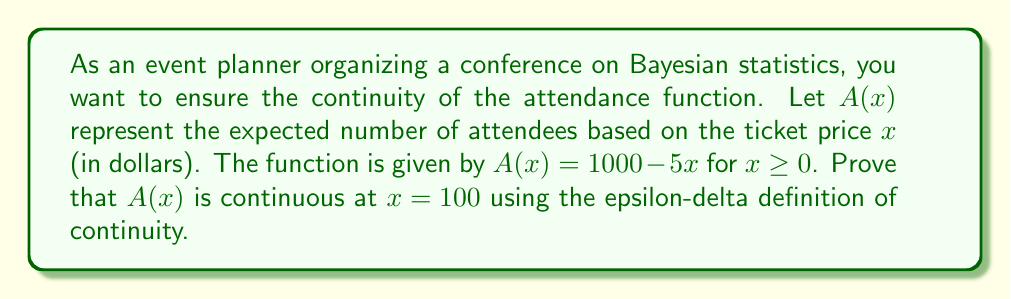Solve this math problem. To prove the continuity of $A(x)$ at $x = 100$ using the epsilon-delta definition, we need to show that for any given $\epsilon > 0$, there exists a $\delta > 0$ such that:

$$|A(x) - A(100)| < \epsilon \text{ whenever } |x - 100| < \delta$$

Let's approach this step-by-step:

1) First, let's calculate $A(100)$:
   $A(100) = 1000 - 5(100) = 500$

2) Now, let's express $|A(x) - A(100)|$ in terms of $|x - 100|$:
   
   $|A(x) - A(100)| = |(1000 - 5x) - (1000 - 5(100))|$
   $= |1000 - 5x - 500|$
   $= |-5x + 500|$
   $= |5(100 - x)|$
   $= 5|100 - x|$
   $= 5|x - 100|$

3) We want this to be less than $\epsilon$:
   
   $5|x - 100| < \epsilon$

4) Solving for $|x - 100|$:
   
   $|x - 100| < \frac{\epsilon}{5}$

5) This suggests that we can choose $\delta = \frac{\epsilon}{5}$

6) To verify, let's check:
   If $|x - 100| < \delta = \frac{\epsilon}{5}$, then:
   
   $|A(x) - A(100)| = 5|x - 100| < 5(\frac{\epsilon}{5}) = \epsilon$

Therefore, for any given $\epsilon > 0$, we can choose $\delta = \frac{\epsilon}{5}$ to satisfy the continuity definition.
Answer: The function $A(x) = 1000 - 5x$ is continuous at $x = 100$. For any $\epsilon > 0$, choose $\delta = \frac{\epsilon}{5}$. Then, $|x - 100| < \delta$ implies $|A(x) - A(100)| < \epsilon$, satisfying the epsilon-delta definition of continuity. 